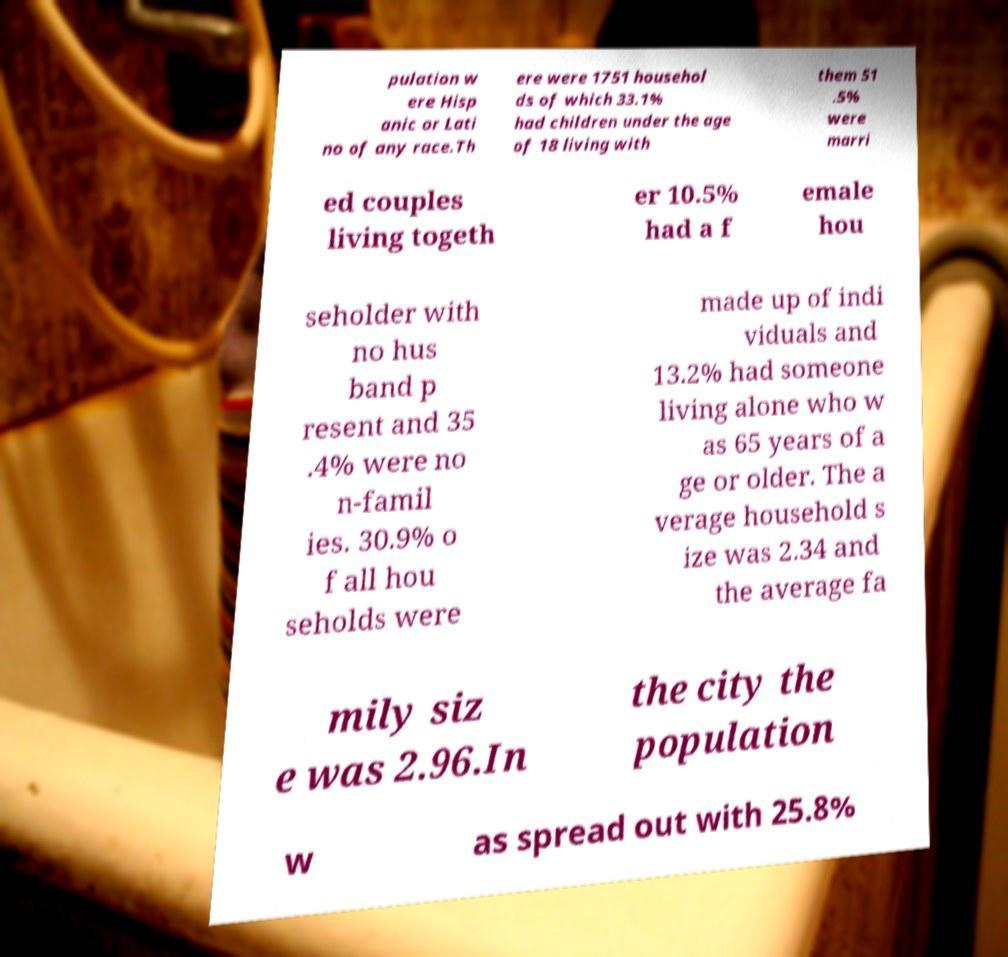Can you accurately transcribe the text from the provided image for me? pulation w ere Hisp anic or Lati no of any race.Th ere were 1751 househol ds of which 33.1% had children under the age of 18 living with them 51 .5% were marri ed couples living togeth er 10.5% had a f emale hou seholder with no hus band p resent and 35 .4% were no n-famil ies. 30.9% o f all hou seholds were made up of indi viduals and 13.2% had someone living alone who w as 65 years of a ge or older. The a verage household s ize was 2.34 and the average fa mily siz e was 2.96.In the city the population w as spread out with 25.8% 